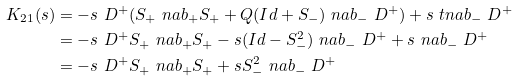<formula> <loc_0><loc_0><loc_500><loc_500>K _ { 2 1 } ( s ) & = - s \ D ^ { + } ( S _ { + } \ n a b _ { + } S _ { + } + Q ( I d + S _ { - } ) \ n a b _ { - } \ D ^ { + } ) + s \ t n a b _ { - } \ D ^ { + } \\ & = - s \ D ^ { + } S _ { + } \ n a b _ { + } S _ { + } - s ( I d - S _ { - } ^ { 2 } ) \ n a b _ { - } \ D ^ { + } + s \ n a b _ { - } \ D ^ { + } \\ & = - s \ D ^ { + } S _ { + } \ n a b _ { + } S _ { + } + s S _ { - } ^ { 2 } \ n a b _ { - } \ D ^ { + }</formula> 